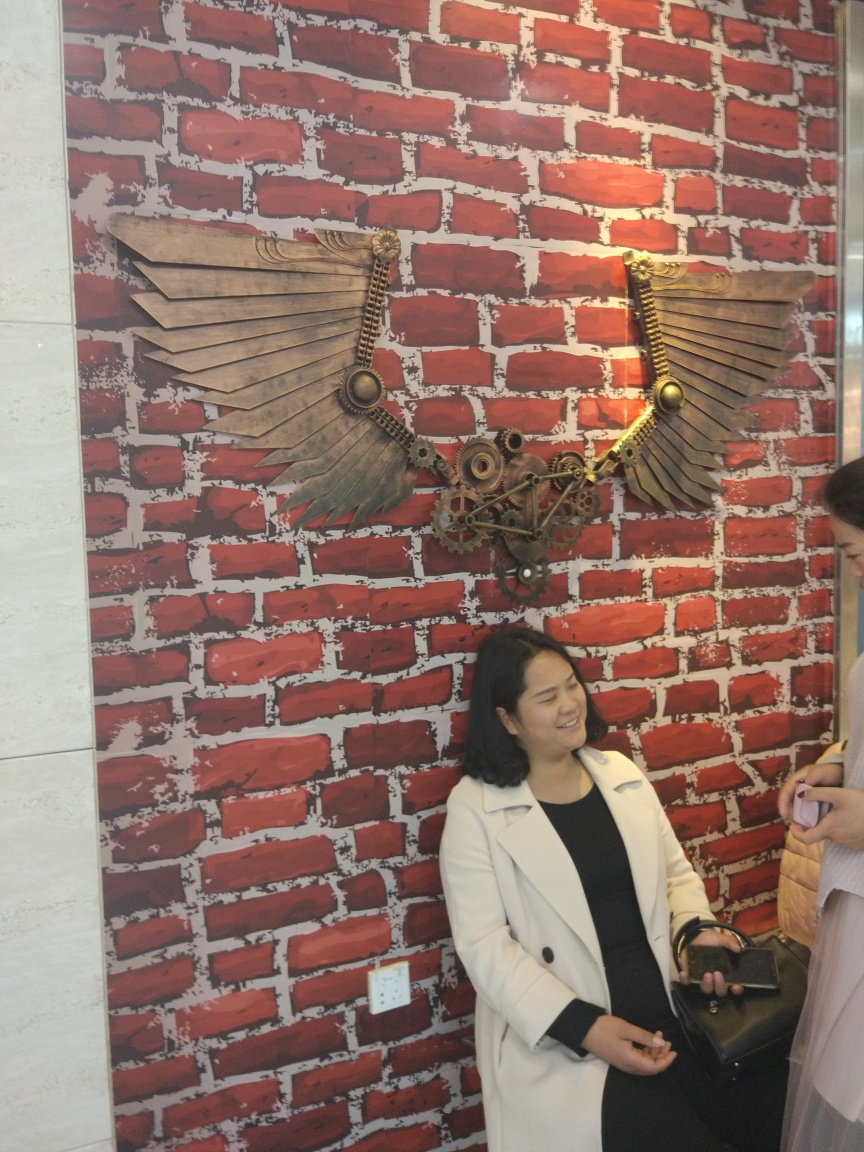What mood does this image convey? The image conveys a cheerful and casual mood. The laughing woman, the relaxed pose, and the warm lighting contribute to a friendly and welcoming atmosphere. The unique decor in the background also adds a touch of creative flair, contributing to an overall positive vibe.  Can you describe the style of the woman's outfit and how it complements the setting? The woman is wearing a classic, sophisticated white coat over a dark outfit, which offers a subtle, yet elegant contrast to the vivid red and white brick wall. Her style is chic and professional, which harmonizes with the artistic and contemporary setting she is in. It suggests stylish flair without overshadowing the bold art piece behind her. 